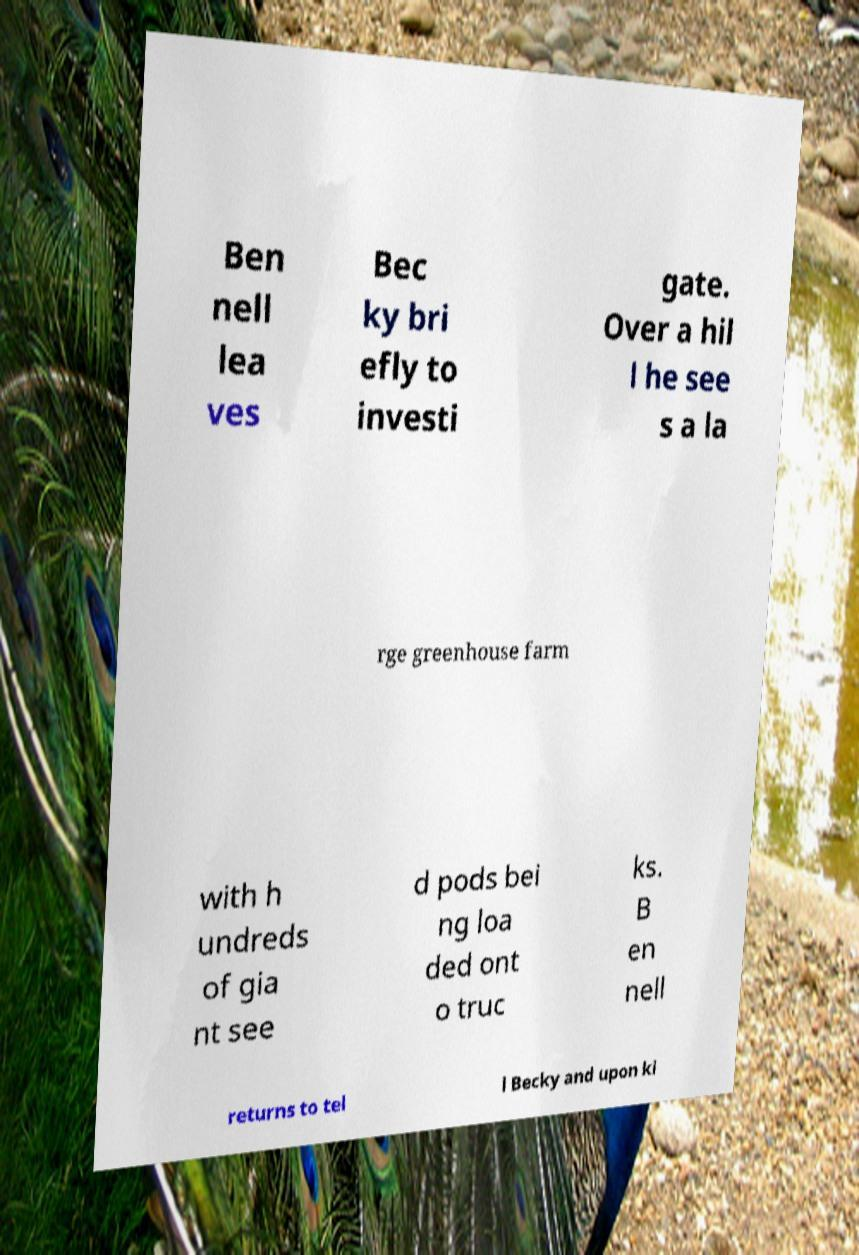Please read and relay the text visible in this image. What does it say? Ben nell lea ves Bec ky bri efly to investi gate. Over a hil l he see s a la rge greenhouse farm with h undreds of gia nt see d pods bei ng loa ded ont o truc ks. B en nell returns to tel l Becky and upon ki 